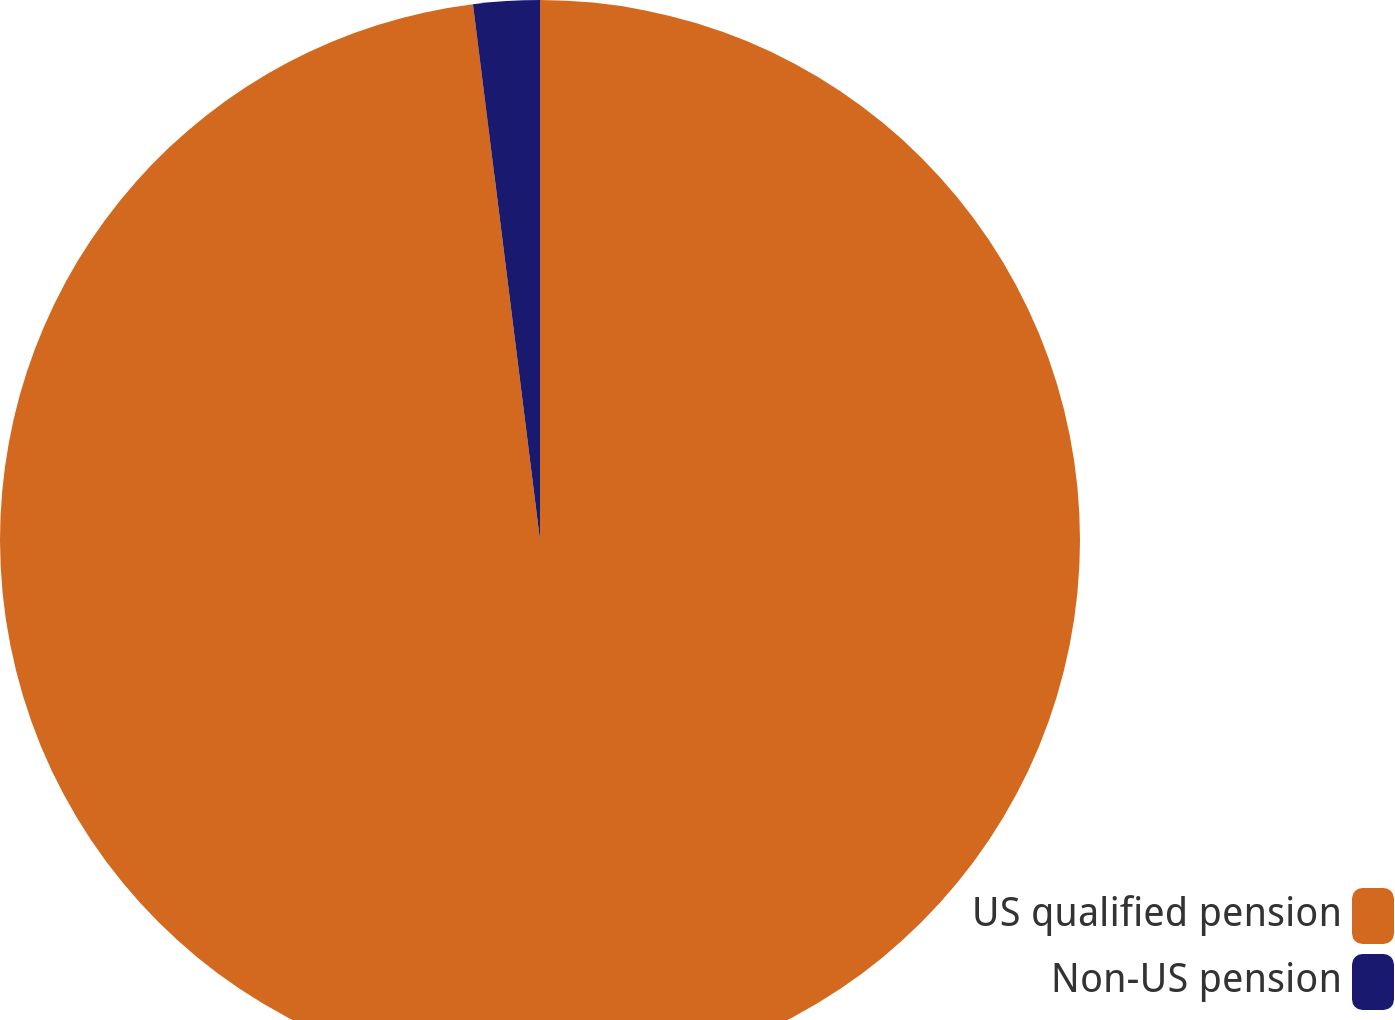Convert chart. <chart><loc_0><loc_0><loc_500><loc_500><pie_chart><fcel>US qualified pension<fcel>Non-US pension<nl><fcel>98.02%<fcel>1.98%<nl></chart> 